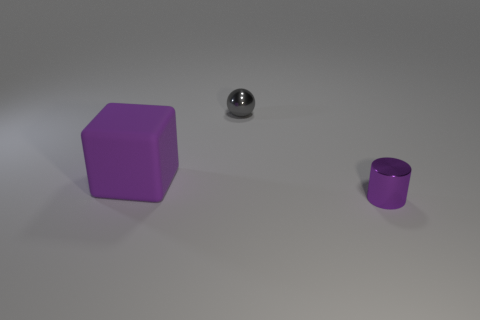Add 2 large blue rubber balls. How many objects exist? 5 Subtract all spheres. How many objects are left? 2 Add 1 big purple things. How many big purple things are left? 2 Add 3 gray things. How many gray things exist? 4 Subtract 0 cyan spheres. How many objects are left? 3 Subtract all large gray matte spheres. Subtract all small shiny cylinders. How many objects are left? 2 